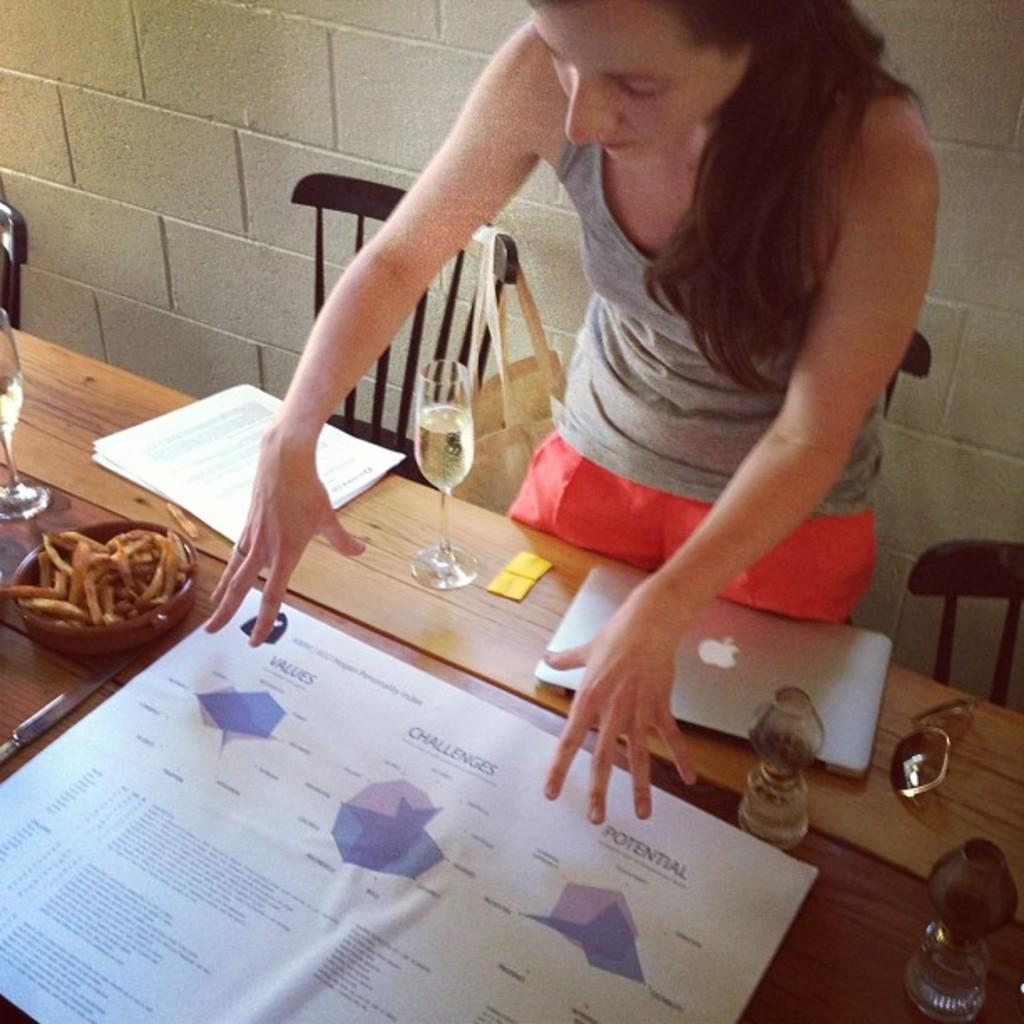What is the woman in the image doing? The woman is standing and looking at a poster on a table. What else can be seen on the table in the image? There are papers, a laptop, a wine glass, and food in a bowl on the table. What might the woman be using the laptop for? It is not clear from the image what the woman is using the laptop for, but it could be for work, browsing, or other purposes. What is the woman's focus in the image? The woman's focus is on the poster on the table. How does the woman's tongue compare to the poster in the image? There is no information about the woman's tongue in the image, so it cannot be compared to the poster. 